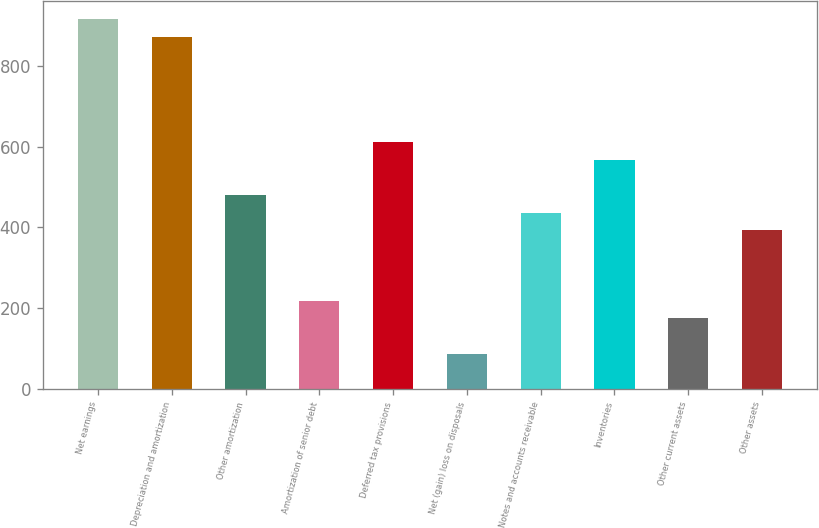Convert chart. <chart><loc_0><loc_0><loc_500><loc_500><bar_chart><fcel>Net earnings<fcel>Depreciation and amortization<fcel>Other amortization<fcel>Amortization of senior debt<fcel>Deferred tax provisions<fcel>Net (gain) loss on disposals<fcel>Notes and accounts receivable<fcel>Inventories<fcel>Other current assets<fcel>Other assets<nl><fcel>915.36<fcel>871.8<fcel>479.76<fcel>218.4<fcel>610.44<fcel>87.72<fcel>436.2<fcel>566.88<fcel>174.84<fcel>392.64<nl></chart> 